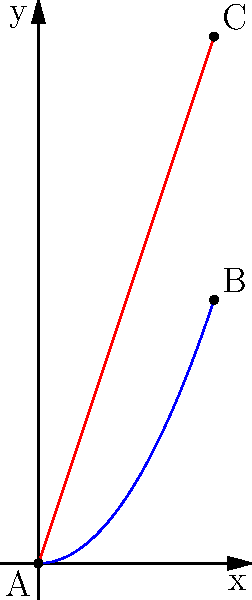As a rural community representative, you're evaluating wind turbine blade efficiency. The curve $y = 0.5x^2$ represents the current blade shape, and the line $y = 3x$ represents the optimal shape for maximum efficiency. Both curves start at point A(0,0) and end at x = 3. Calculate the area between these two curves to determine the efficiency loss. What percentage of the optimal area does this loss represent? Let's approach this step-by-step:

1) The area between the curves represents the efficiency loss. We need to calculate this area and compare it to the area under the optimal line.

2) Area between curves = $\int_0^3 (3x - 0.5x^2) dx$

3) Integrating:
   $\int_0^3 (3x - 0.5x^2) dx = [1.5x^2 - \frac{1}{6}x^3]_0^3$
   $= (13.5 - 4.5) - (0 - 0) = 9$

4) The area under the optimal line (triangle ABC):
   Area = $\frac{1}{2} * base * height = \frac{1}{2} * 3 * 9 = 13.5$

5) Efficiency loss percentage:
   $\frac{\text{Area between curves}}{\text{Area under optimal line}} * 100\%$
   $= \frac{9}{13.5} * 100\% = 66.67\%$

Therefore, the efficiency loss is about 66.67% of the optimal area.
Answer: 66.67% 